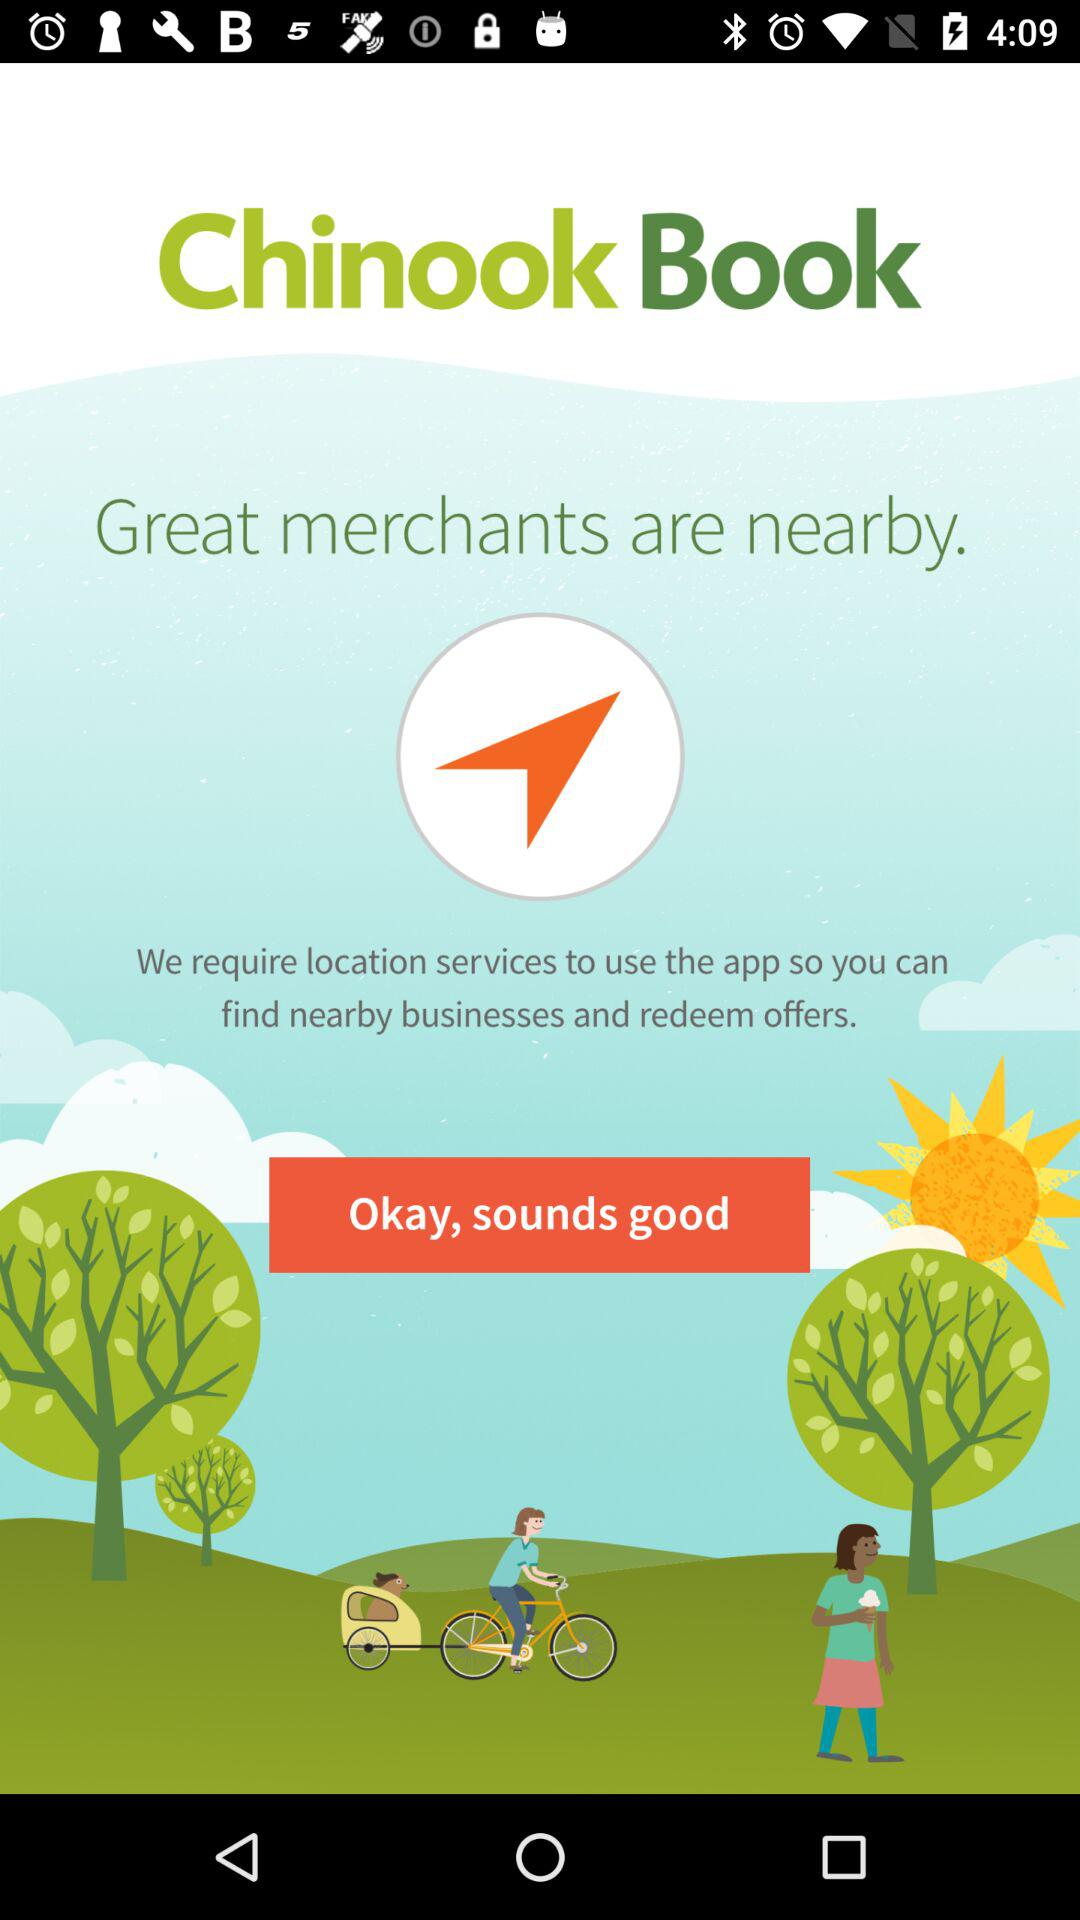What is the name of the application? The name of the application is "Chinook Book". 